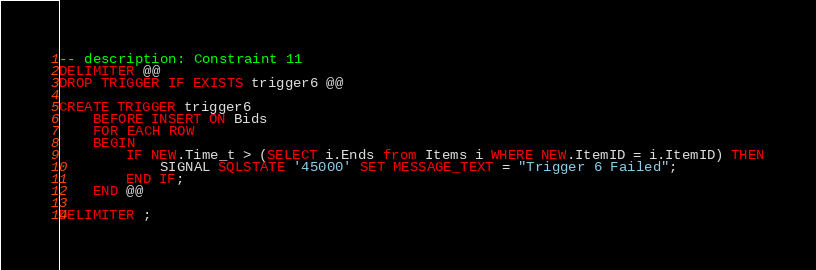Convert code to text. <code><loc_0><loc_0><loc_500><loc_500><_SQL_>-- description: Constraint 11
DELIMITER @@
DROP TRIGGER IF EXISTS trigger6 @@

CREATE TRIGGER trigger6
	BEFORE INSERT ON Bids
    FOR EACH ROW 
    BEGIN
    	IF NEW.Time_t > (SELECT i.Ends from Items i WHERE NEW.ItemID = i.ItemID) THEN
      		SIGNAL SQLSTATE '45000' SET MESSAGE_TEXT = "Trigger 6 Failed";
        END IF;
    END @@
    
DELIMITER ;</code> 